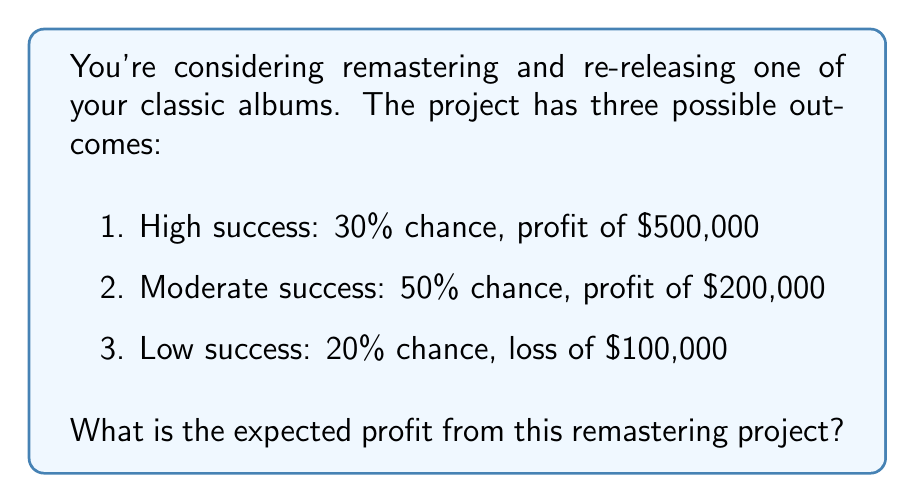Can you solve this math problem? To calculate the expected profit, we need to use the concept of expected value. The expected value is the sum of each possible outcome multiplied by its probability.

Let's break it down step-by-step:

1) For high success:
   Probability = 30% = 0.3
   Profit = $500,000
   Expected value = $500,000 * 0.3 = $150,000

2) For moderate success:
   Probability = 50% = 0.5
   Profit = $200,000
   Expected value = $200,000 * 0.5 = $100,000

3) For low success:
   Probability = 20% = 0.2
   Loss = $100,000 (note this is negative profit)
   Expected value = -$100,000 * 0.2 = -$20,000

Now, we sum these expected values:

$$\text{Expected Profit} = 150,000 + 100,000 + (-20,000) = 230,000$$

Therefore, the expected profit from the remastering project is $230,000.
Answer: $230,000 